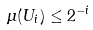<formula> <loc_0><loc_0><loc_500><loc_500>\mu ( U _ { i } ) \leq 2 ^ { - i }</formula> 